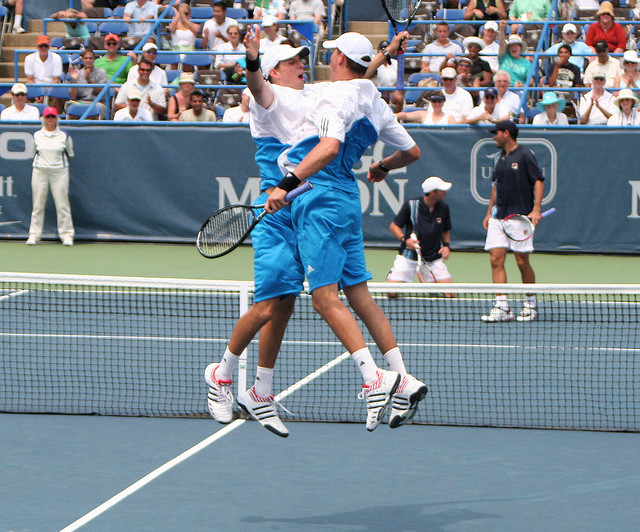Please extract the text content from this image. O 